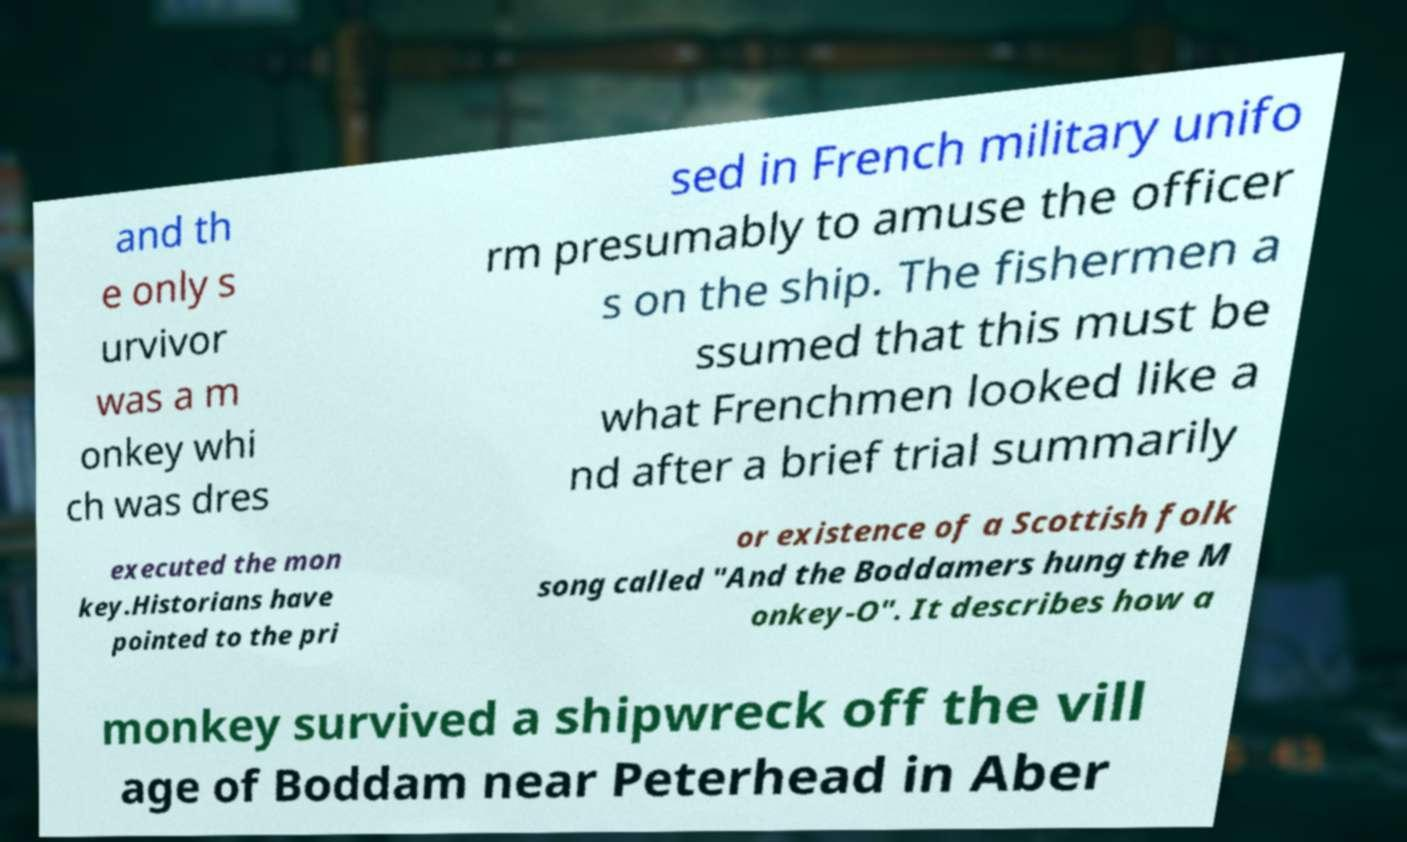For documentation purposes, I need the text within this image transcribed. Could you provide that? and th e only s urvivor was a m onkey whi ch was dres sed in French military unifo rm presumably to amuse the officer s on the ship. The fishermen a ssumed that this must be what Frenchmen looked like a nd after a brief trial summarily executed the mon key.Historians have pointed to the pri or existence of a Scottish folk song called "And the Boddamers hung the M onkey-O". It describes how a monkey survived a shipwreck off the vill age of Boddam near Peterhead in Aber 